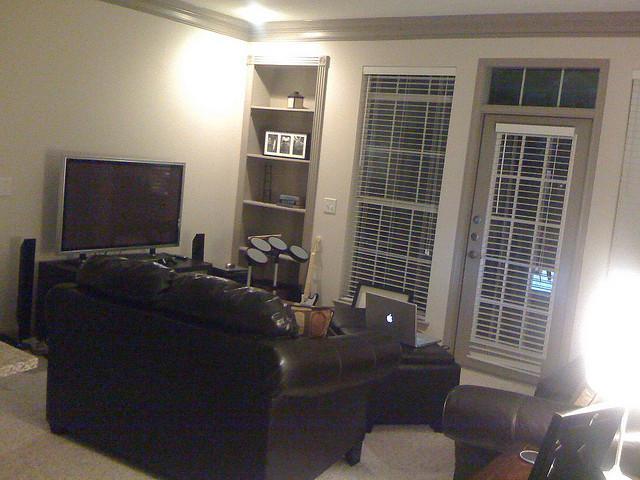How many chairs are in the photo?
Give a very brief answer. 2. How many couches can be seen?
Give a very brief answer. 2. How many people are there?
Give a very brief answer. 0. 